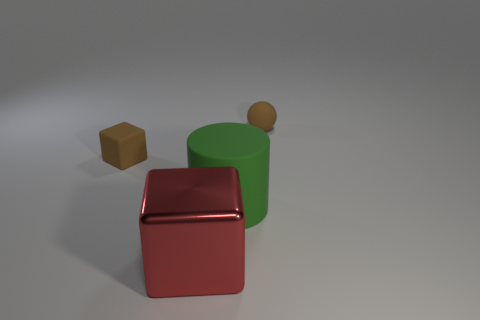Are there any other things that have the same material as the large red thing?
Your answer should be very brief. No. There is a small brown object that is on the left side of the big green cylinder; is there a rubber sphere that is to the left of it?
Keep it short and to the point. No. There is a brown object that is made of the same material as the tiny brown cube; what is its shape?
Your answer should be compact. Sphere. Is there any other thing that is the same color as the big metal object?
Keep it short and to the point. No. There is another tiny thing that is the same shape as the red thing; what is it made of?
Offer a very short reply. Rubber. How many other objects are there of the same size as the metallic thing?
Ensure brevity in your answer.  1. There is a matte ball that is the same color as the small matte block; what size is it?
Offer a very short reply. Small. There is a brown object left of the small brown rubber ball; is it the same shape as the big red thing?
Keep it short and to the point. Yes. What number of other things are the same shape as the large metal thing?
Your answer should be compact. 1. There is a tiny brown object that is right of the red metallic object; what shape is it?
Provide a short and direct response. Sphere. 